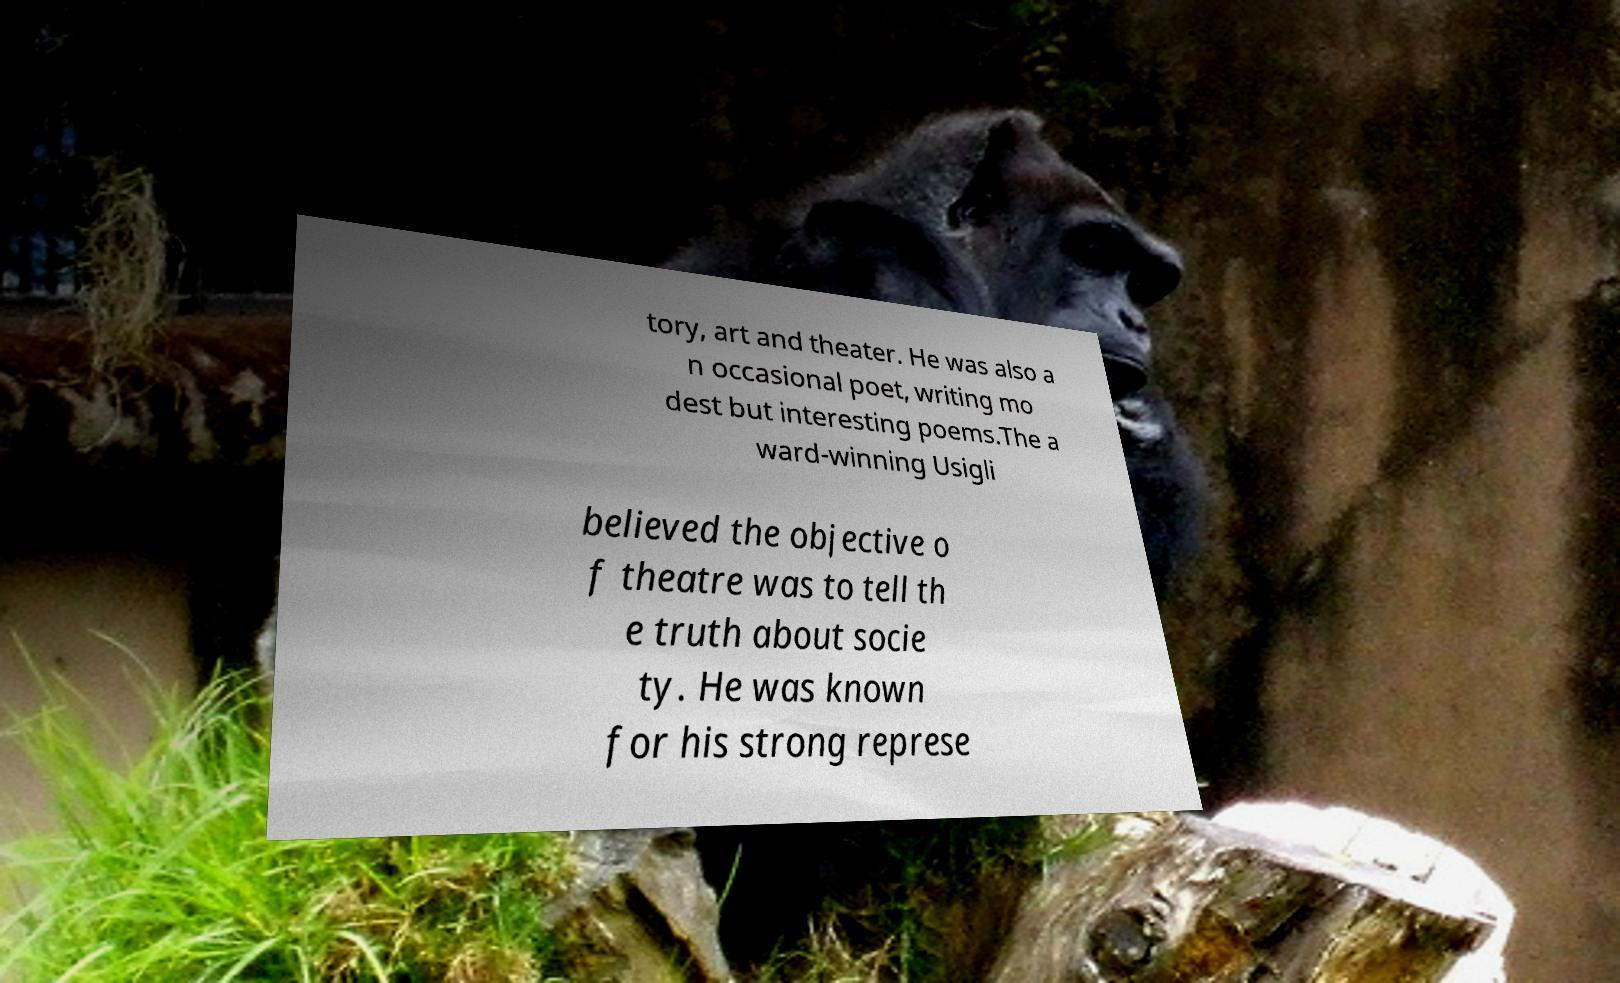Could you assist in decoding the text presented in this image and type it out clearly? tory, art and theater. He was also a n occasional poet, writing mo dest but interesting poems.The a ward-winning Usigli believed the objective o f theatre was to tell th e truth about socie ty. He was known for his strong represe 